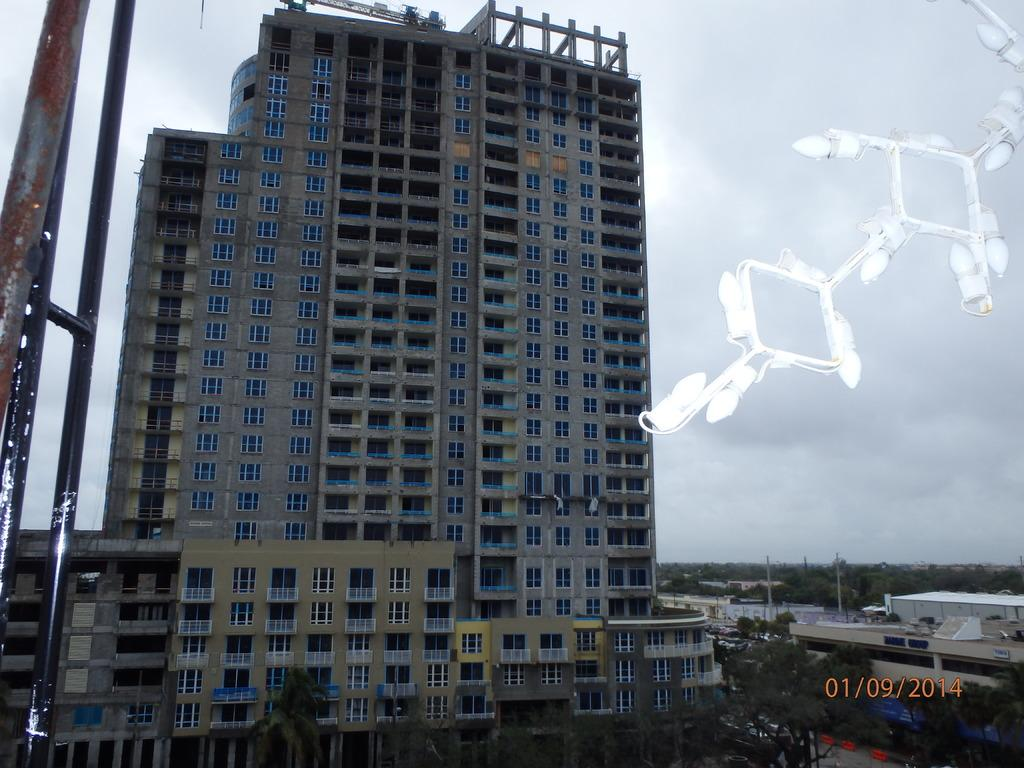What type of structure is present in the image? There is a building in the image. What other natural elements can be seen in the image? There are trees in the image. What is visible at the top of the image? The sky is visible at the top of the image. How many kittens are playing with the horn on the building in the image? There are no kittens or horns present in the image. What type of planes can be seen flying in the sky in the image? There are no planes visible in the sky in the image. 